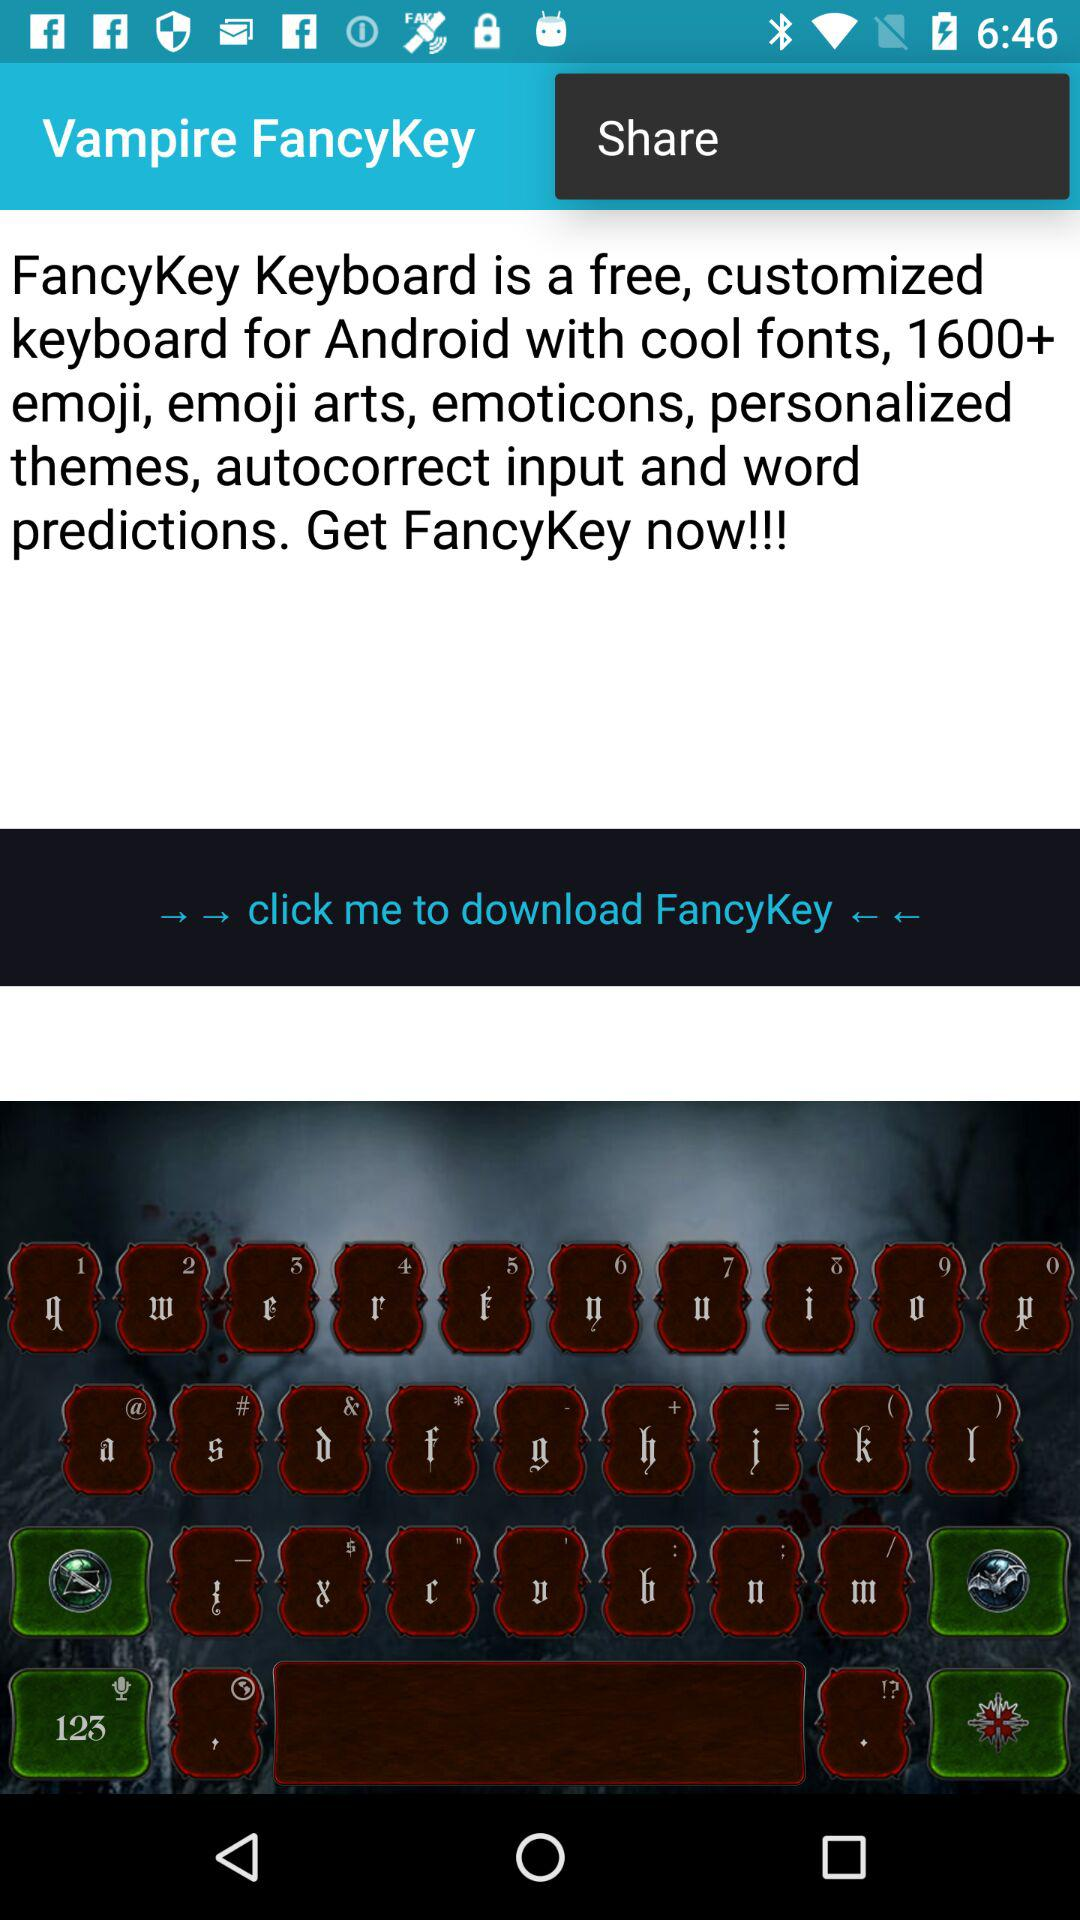What is the application name? The application name is "FancyKey". 